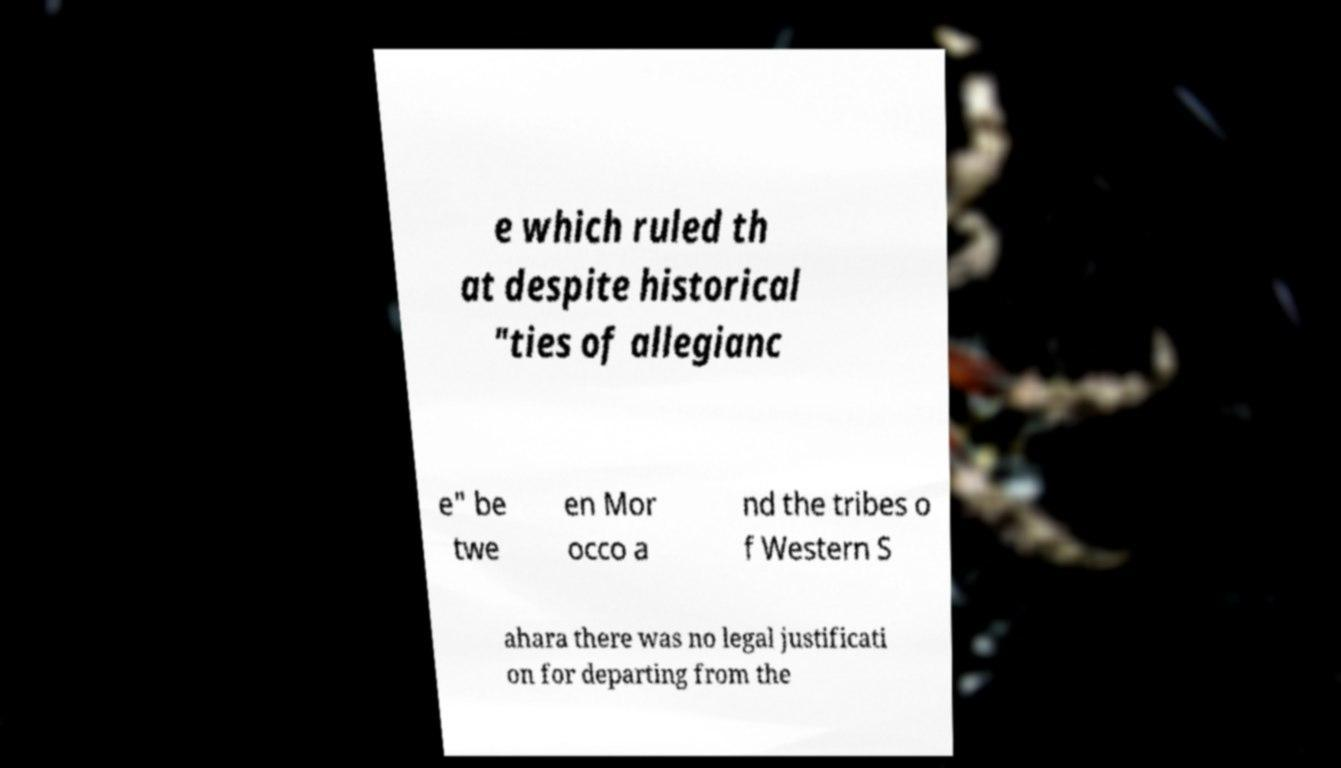Please read and relay the text visible in this image. What does it say? e which ruled th at despite historical "ties of allegianc e" be twe en Mor occo a nd the tribes o f Western S ahara there was no legal justificati on for departing from the 